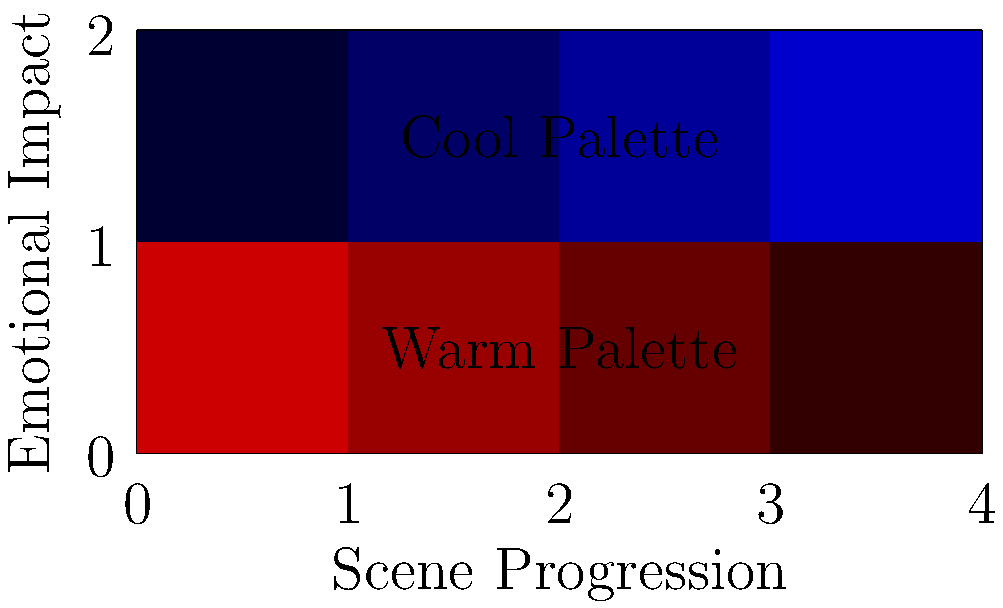As a foreign film enthusiast, you're analyzing the emotional impact of color palettes in a critically acclaimed international drama. The graph shows the use of warm (red) and cool (blue) color palettes across scenes. How might the shift from warm to cool colors affect the audience's emotional response, and what narrative purpose could this serve? To answer this question, let's analyze the graph and consider the emotional associations of color:

1. Color progression:
   - The warm palette (red) decreases in intensity from left to right.
   - The cool palette (blue) increases in intensity from left to right.

2. Emotional associations:
   - Warm colors (red): Often associated with passion, energy, warmth, and intensity.
   - Cool colors (blue): Often associated with calmness, sadness, introspection, and distance.

3. Narrative implications:
   - The shift from warm to cool suggests a transition in the story's emotional tone.
   - It could indicate a change in the protagonist's emotional state or the overall mood of the film.

4. Possible interpretations:
   - The story might start with high energy or passion and gradually become more somber or reflective.
   - Characters could be moving from a state of emotional intensity to one of calm or detachment.
   - The setting might transition from a warm, comforting environment to a cooler, more alienating one.

5. Audience response:
   - Viewers may unconsciously pick up on this color shift, feeling more energized at the beginning and more contemplative towards the end.
   - This could enhance the emotional journey of the characters and deepen the audience's engagement with the narrative.

6. Cinematic technique:
   - This use of color demonstrates how filmmakers can use visual elements to subtly influence audience emotions and support storytelling.

The gradual shift in color palette serves to guide the audience's emotional response, potentially reflecting the narrative arc from passionate beginnings to a more introspective or melancholic conclusion.
Answer: Transition from intensity to introspection, supporting character/narrative development 